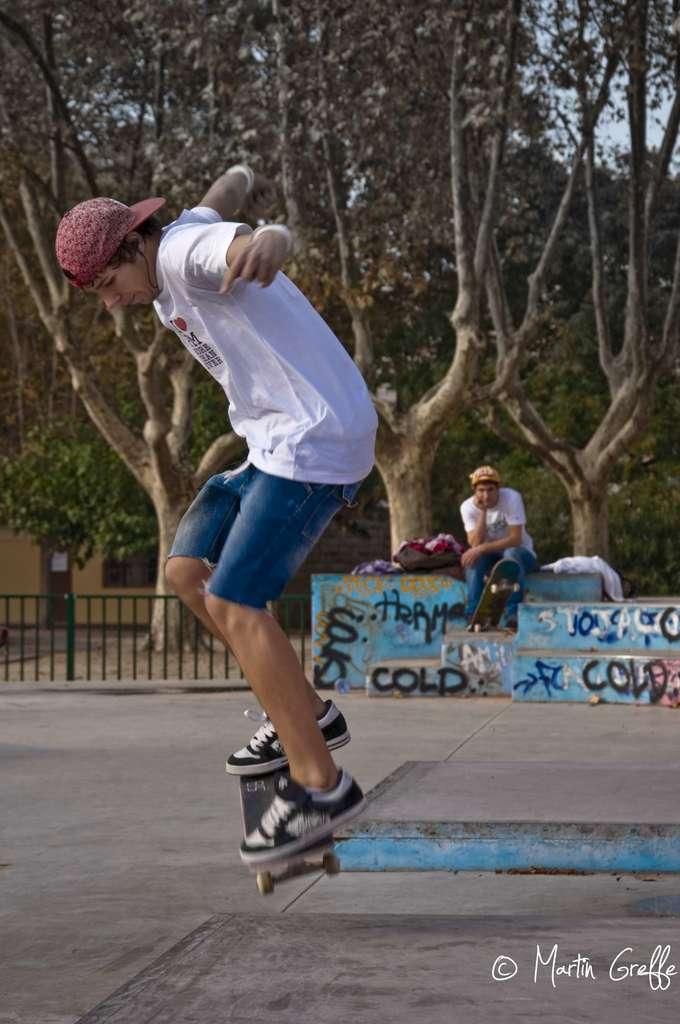What is the main subject of the image? The main subject of the image is a man. What is the man wearing on his head? The man is wearing a cap. What type of footwear is the man wearing? The man is wearing shoes. What is the man doing in the image? The man is standing on a skateboard. What can be seen in the background of the image? In the background, there is a fence, trees, clothes, another skateboard, and a man sitting. What type of umbrella is the judge holding in the image? There is no judge or umbrella present in the image. How many sticks are visible in the image? There are no sticks visible in the image. 